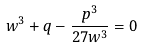Convert formula to latex. <formula><loc_0><loc_0><loc_500><loc_500>w ^ { 3 } + q - \frac { p ^ { 3 } } { 2 7 w ^ { 3 } } = 0</formula> 